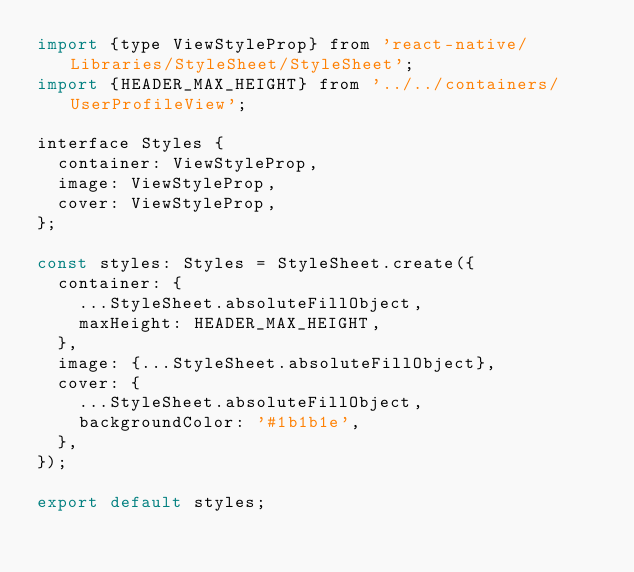<code> <loc_0><loc_0><loc_500><loc_500><_JavaScript_>import {type ViewStyleProp} from 'react-native/Libraries/StyleSheet/StyleSheet';
import {HEADER_MAX_HEIGHT} from '../../containers/UserProfileView';

interface Styles {
  container: ViewStyleProp,
  image: ViewStyleProp,
  cover: ViewStyleProp,
};

const styles: Styles = StyleSheet.create({
  container: {
    ...StyleSheet.absoluteFillObject,
    maxHeight: HEADER_MAX_HEIGHT,
  },
  image: {...StyleSheet.absoluteFillObject},
  cover: {
    ...StyleSheet.absoluteFillObject,
    backgroundColor: '#1b1b1e',
  },
});

export default styles;</code> 